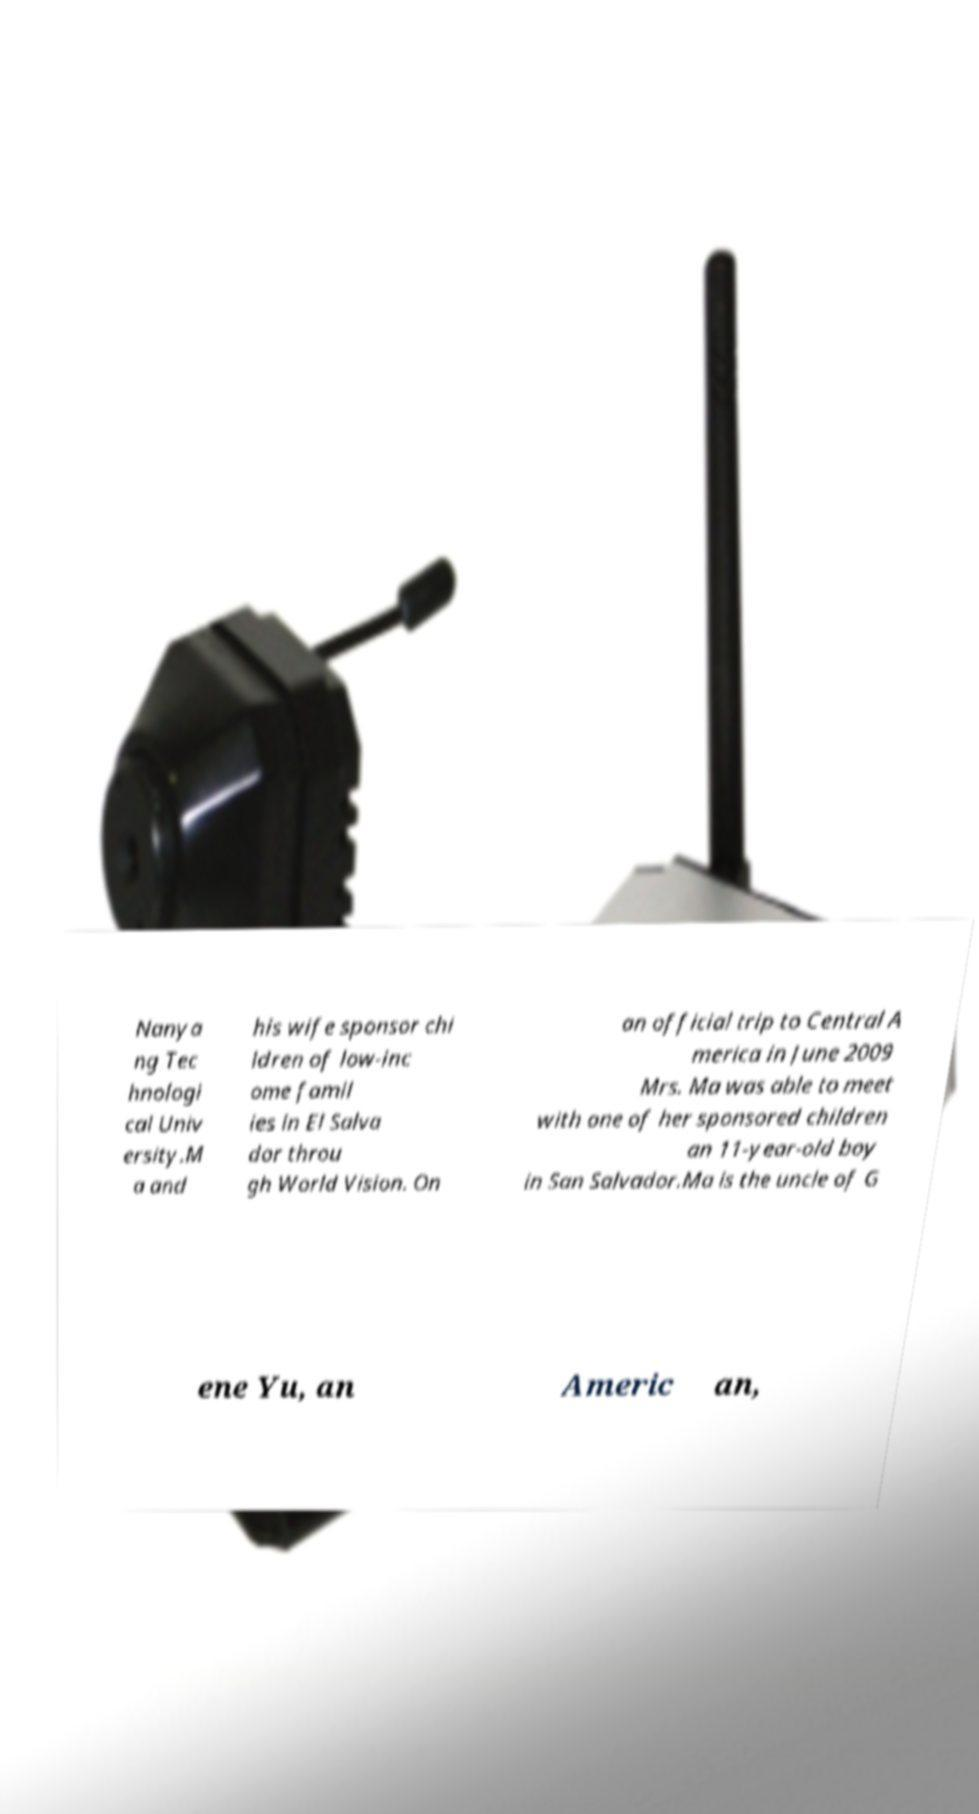Could you assist in decoding the text presented in this image and type it out clearly? Nanya ng Tec hnologi cal Univ ersity.M a and his wife sponsor chi ldren of low-inc ome famil ies in El Salva dor throu gh World Vision. On an official trip to Central A merica in June 2009 Mrs. Ma was able to meet with one of her sponsored children an 11-year-old boy in San Salvador.Ma is the uncle of G ene Yu, an Americ an, 